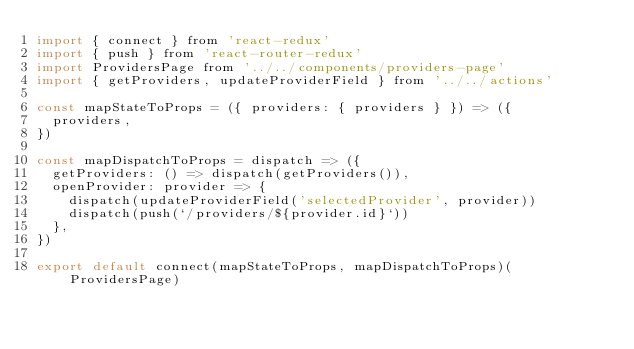<code> <loc_0><loc_0><loc_500><loc_500><_JavaScript_>import { connect } from 'react-redux'
import { push } from 'react-router-redux'
import ProvidersPage from '../../components/providers-page'
import { getProviders, updateProviderField } from '../../actions'

const mapStateToProps = ({ providers: { providers } }) => ({
  providers,
})

const mapDispatchToProps = dispatch => ({
  getProviders: () => dispatch(getProviders()),
  openProvider: provider => {
    dispatch(updateProviderField('selectedProvider', provider))
    dispatch(push(`/providers/${provider.id}`))
  },
})

export default connect(mapStateToProps, mapDispatchToProps)(ProvidersPage)
</code> 